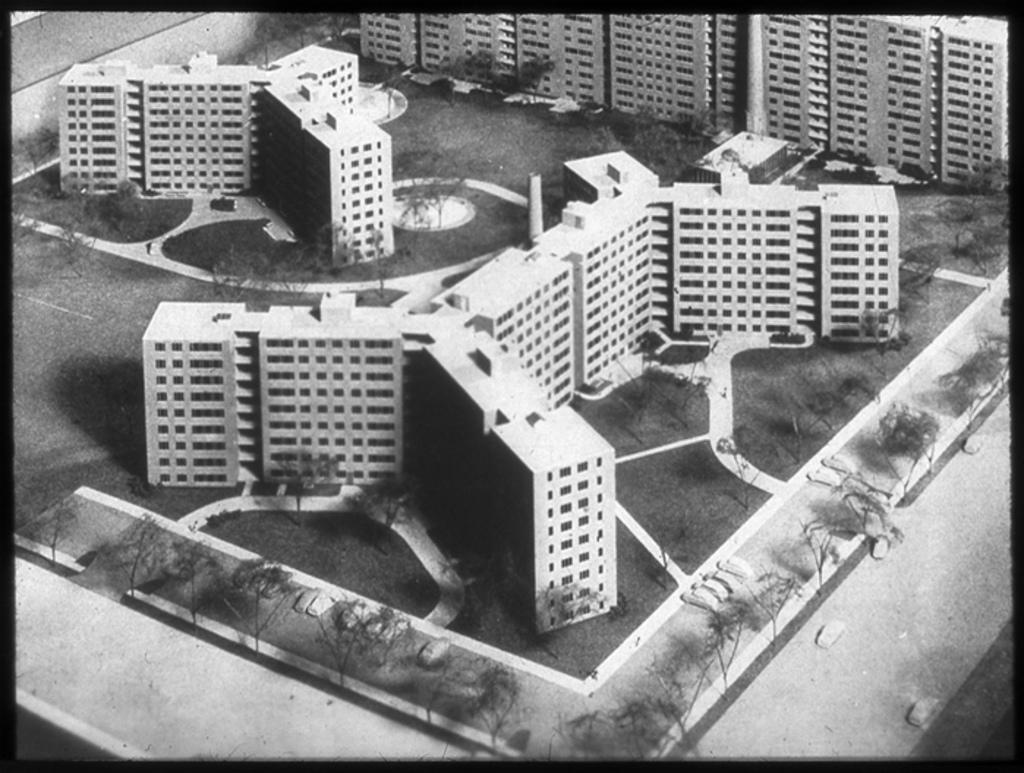Could you give a brief overview of what you see in this image? This is a black and white pic. We can see buildings, grass on the ground, trees, vehicles on the road and objects. 